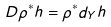<formula> <loc_0><loc_0><loc_500><loc_500>D \rho ^ { * } h = \rho ^ { * } d _ { Y } h</formula> 